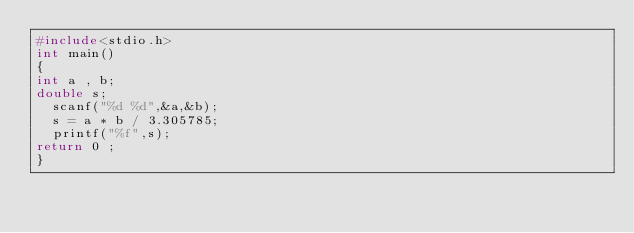<code> <loc_0><loc_0><loc_500><loc_500><_C_>#include<stdio.h>
int main()
{
int a , b;
double s;
	scanf("%d %d",&a,&b);
	s = a * b / 3.305785;
	printf("%f",s);
return 0 ;
}</code> 